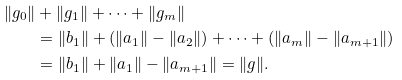Convert formula to latex. <formula><loc_0><loc_0><loc_500><loc_500>\| g _ { 0 } \| & + \| g _ { 1 } \| + \cdots + \| g _ { m } \| \\ & = \| b _ { 1 } \| + ( \| a _ { 1 } \| - \| a _ { 2 } \| ) + \cdots + ( \| a _ { m } \| - \| a _ { m + 1 } \| ) \\ & = \| b _ { 1 } \| + \| a _ { 1 } \| - \| a _ { m + 1 } \| = \| g \| .</formula> 